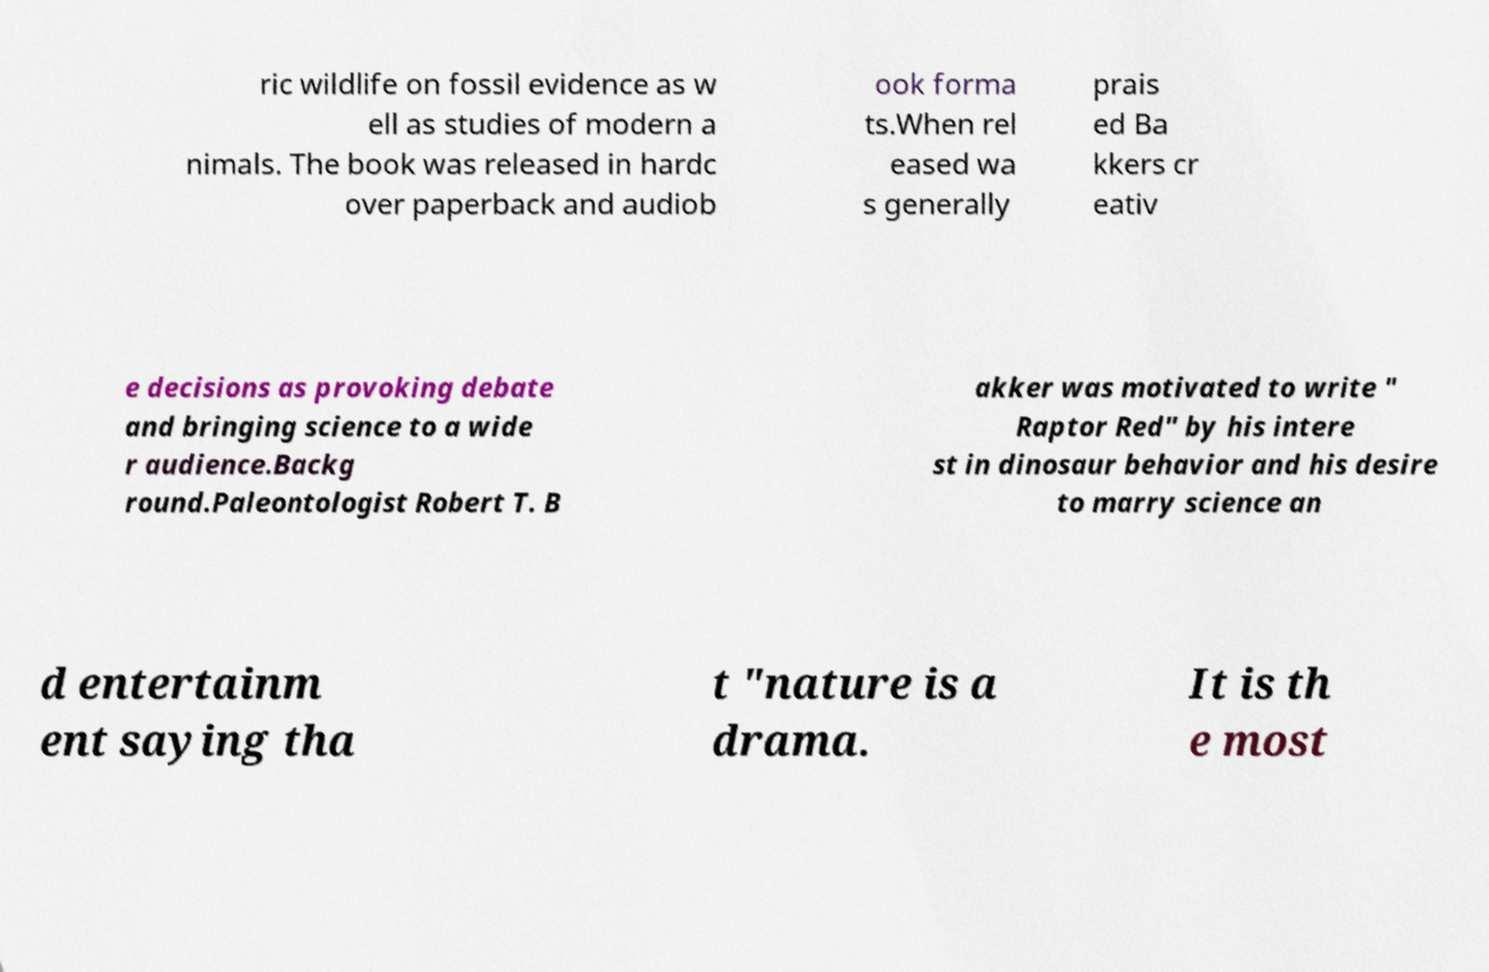I need the written content from this picture converted into text. Can you do that? ric wildlife on fossil evidence as w ell as studies of modern a nimals. The book was released in hardc over paperback and audiob ook forma ts.When rel eased wa s generally prais ed Ba kkers cr eativ e decisions as provoking debate and bringing science to a wide r audience.Backg round.Paleontologist Robert T. B akker was motivated to write " Raptor Red" by his intere st in dinosaur behavior and his desire to marry science an d entertainm ent saying tha t "nature is a drama. It is th e most 